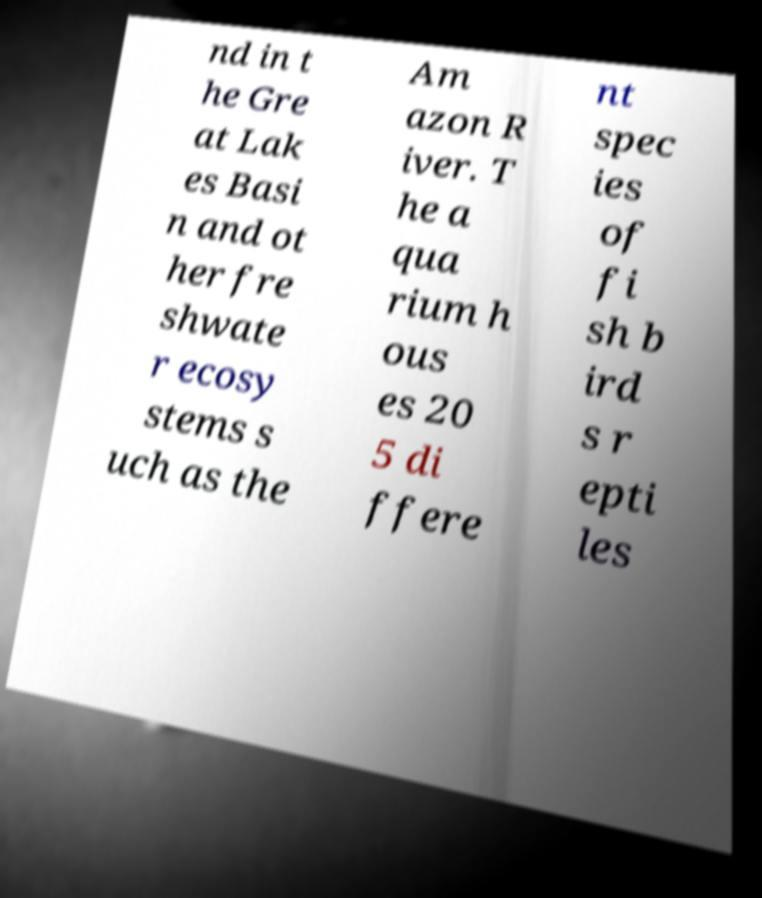Can you read and provide the text displayed in the image?This photo seems to have some interesting text. Can you extract and type it out for me? nd in t he Gre at Lak es Basi n and ot her fre shwate r ecosy stems s uch as the Am azon R iver. T he a qua rium h ous es 20 5 di ffere nt spec ies of fi sh b ird s r epti les 